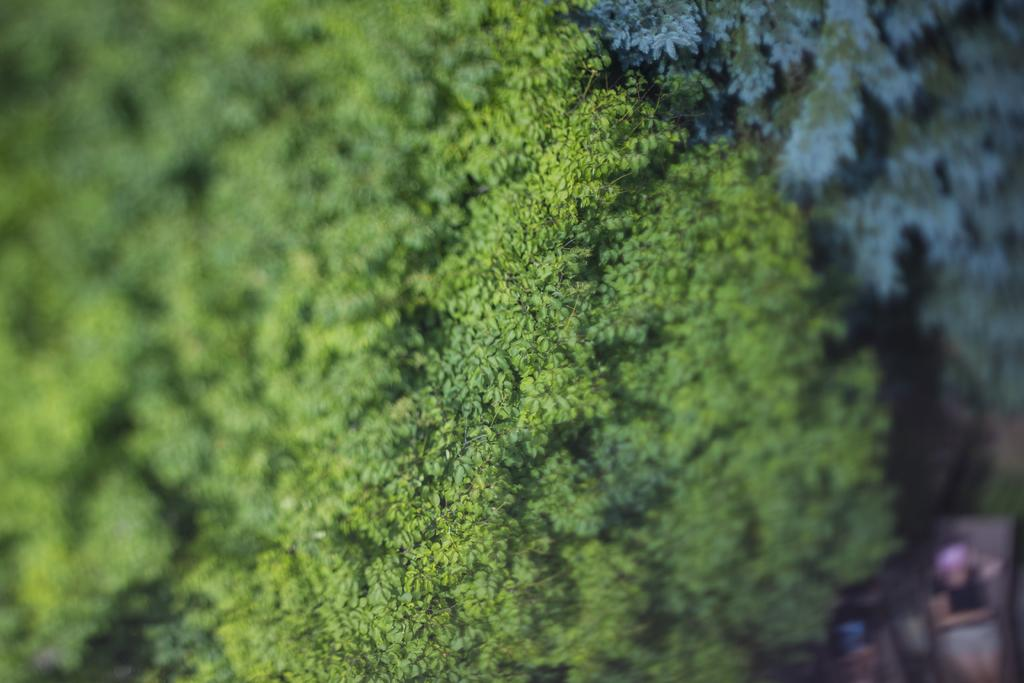What type of plant can be seen in the image? There is a tree in the image. Are there any living beings present in the image? Yes, there is a human standing in the image. How many birds are sitting on the branches of the tree in the image? There are no birds present in the image; it only features a tree and a human. Is there a jail visible in the image? There is no jail present in the image. 